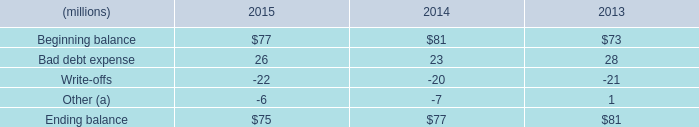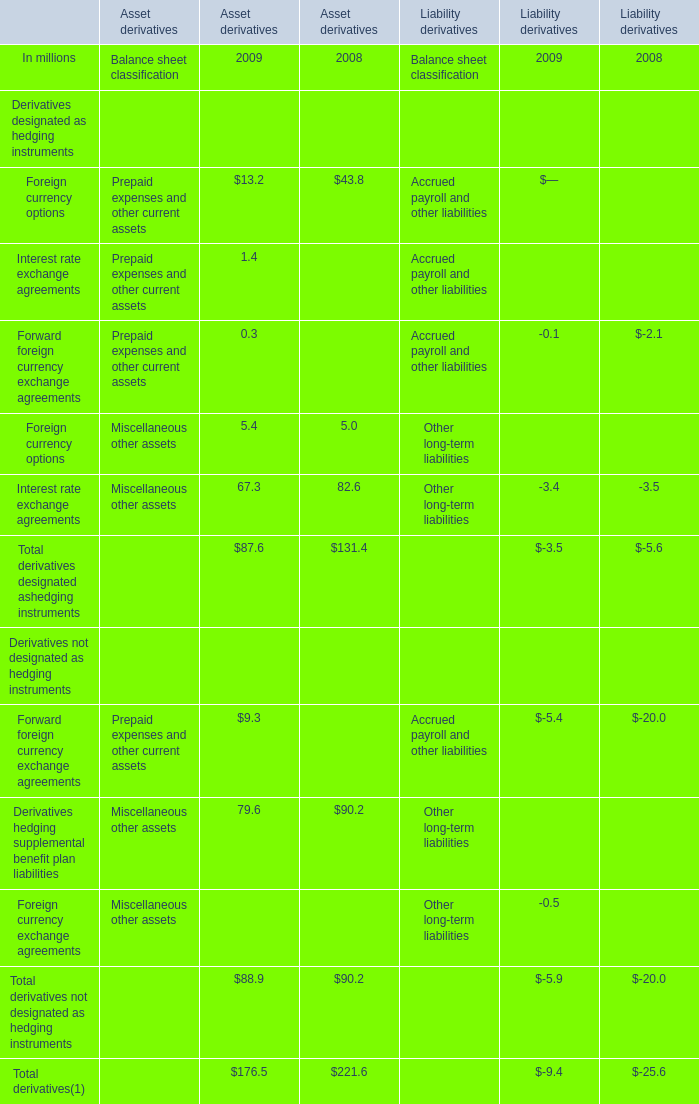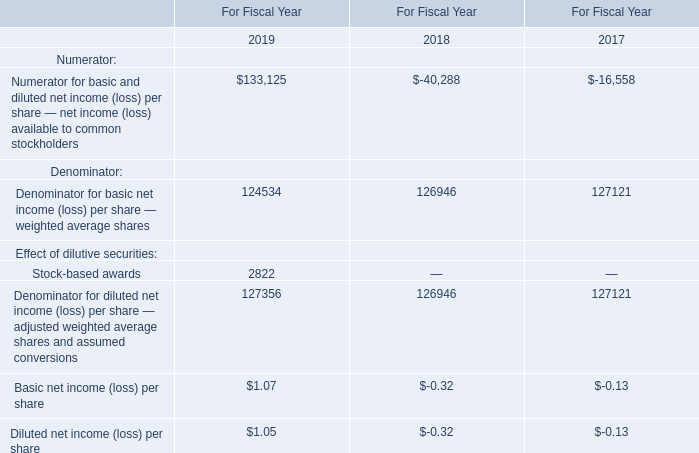In which year is Foreign currency options for Asset derivatives greater than 40? 
Answer: 2008. 